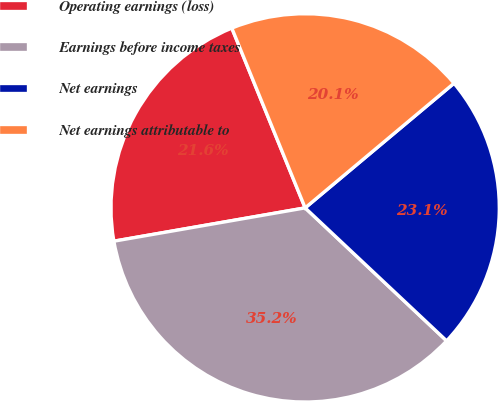<chart> <loc_0><loc_0><loc_500><loc_500><pie_chart><fcel>Operating earnings (loss)<fcel>Earnings before income taxes<fcel>Net earnings<fcel>Net earnings attributable to<nl><fcel>21.58%<fcel>35.25%<fcel>23.1%<fcel>20.07%<nl></chart> 